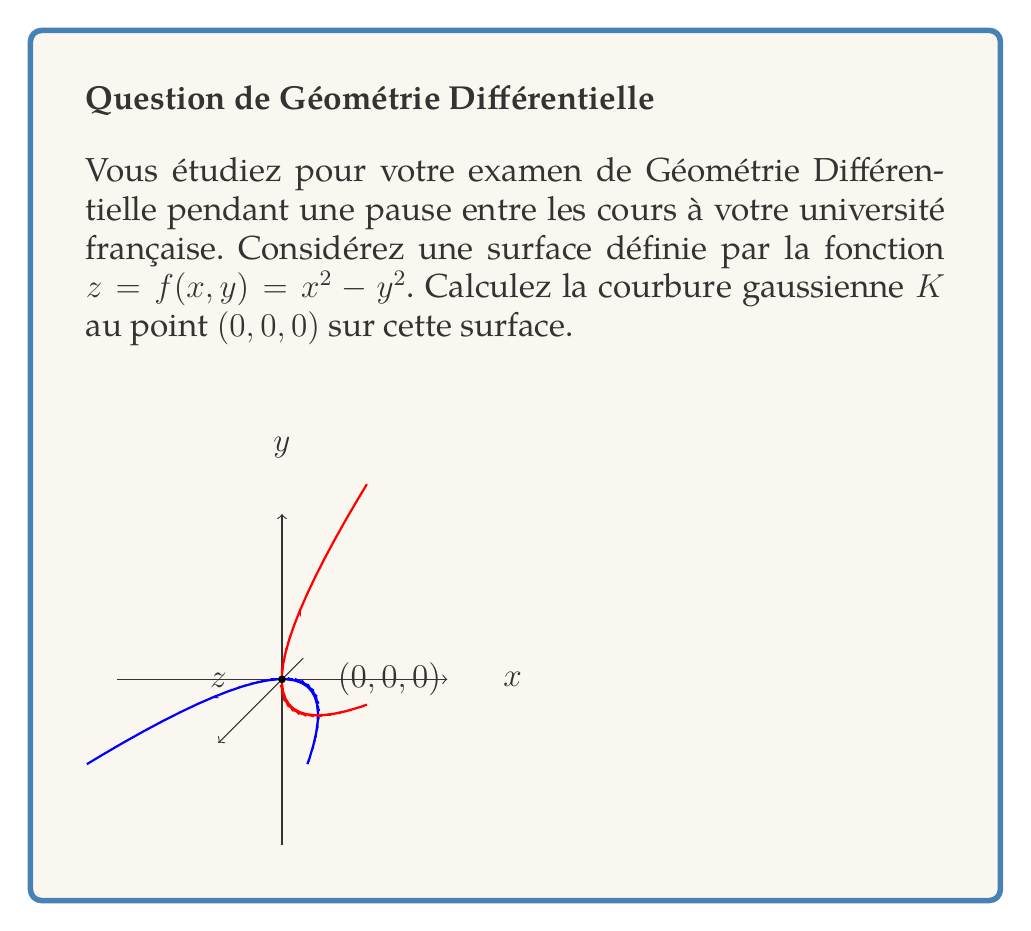Provide a solution to this math problem. Let's approach this step-by-step:

1) The Gaussian curvature $K$ is given by $K = \frac{LN - M^2}{EG - F^2}$, where $L$, $M$, $N$ are coefficients of the second fundamental form, and $E$, $F$, $G$ are coefficients of the first fundamental form.

2) For a surface $z = f(x,y)$, we have:
   $E = 1 + (\frac{\partial f}{\partial x})^2$
   $F = \frac{\partial f}{\partial x}\frac{\partial f}{\partial y}$
   $G = 1 + (\frac{\partial f}{\partial y})^2$
   $L = \frac{\frac{\partial^2 f}{\partial x^2}}{\sqrt{1+(\frac{\partial f}{\partial x})^2+(\frac{\partial f}{\partial y})^2}}$
   $M = \frac{\frac{\partial^2 f}{\partial x\partial y}}{\sqrt{1+(\frac{\partial f}{\partial x})^2+(\frac{\partial f}{\partial y})^2}}$
   $N = \frac{\frac{\partial^2 f}{\partial y^2}}{\sqrt{1+(\frac{\partial f}{\partial x})^2+(\frac{\partial f}{\partial y})^2}}$

3) Let's calculate these values:
   $\frac{\partial f}{\partial x} = 2x$
   $\frac{\partial f}{\partial y} = -2y$
   $\frac{\partial^2 f}{\partial x^2} = 2$
   $\frac{\partial^2 f}{\partial y^2} = -2$
   $\frac{\partial^2 f}{\partial x\partial y} = 0$

4) At point $(0,0,0)$:
   $E = 1 + (0)^2 = 1$
   $F = (0)(0) = 0$
   $G = 1 + (0)^2 = 1$
   $L = \frac{2}{\sqrt{1+0^2+0^2}} = 2$
   $M = \frac{0}{\sqrt{1+0^2+0^2}} = 0$
   $N = \frac{-2}{\sqrt{1+0^2+0^2}} = -2$

5) Now we can calculate $K$:
   $K = \frac{LN - M^2}{EG - F^2} = \frac{(2)(-2) - (0)^2}{(1)(1) - (0)^2} = \frac{-4}{1} = -4$

Therefore, the Gaussian curvature at point $(0,0,0)$ is $-4$.
Answer: $K = -4$ 